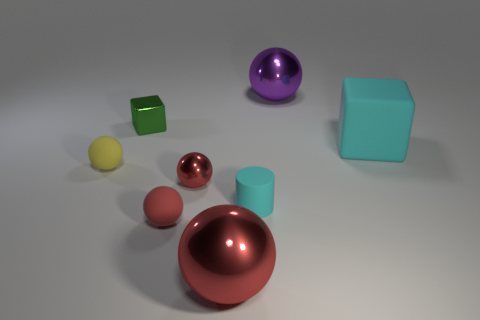How many red spheres must be subtracted to get 1 red spheres? 2 Subtract all red matte spheres. How many spheres are left? 4 Add 2 small yellow rubber balls. How many objects exist? 10 Subtract all yellow balls. How many balls are left? 4 Subtract all balls. How many objects are left? 3 Add 4 yellow matte objects. How many yellow matte objects exist? 5 Subtract 1 red balls. How many objects are left? 7 Subtract 1 cylinders. How many cylinders are left? 0 Subtract all brown cubes. Subtract all gray spheres. How many cubes are left? 2 Subtract all cyan cylinders. How many green cubes are left? 1 